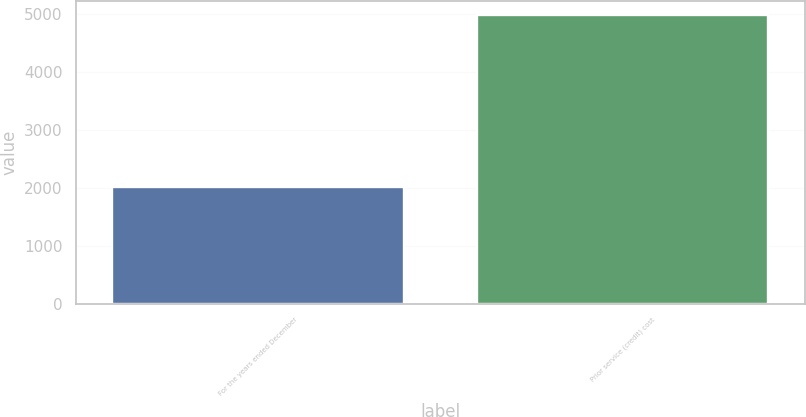Convert chart. <chart><loc_0><loc_0><loc_500><loc_500><bar_chart><fcel>For the years ended December<fcel>Prior service (credit) cost<nl><fcel>2007<fcel>4975<nl></chart> 